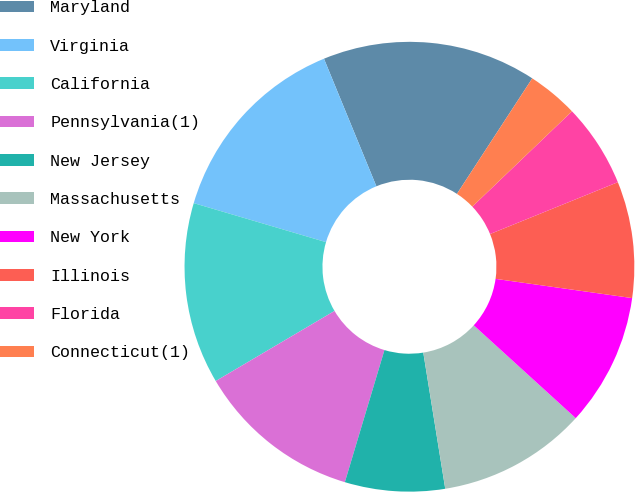Convert chart to OTSL. <chart><loc_0><loc_0><loc_500><loc_500><pie_chart><fcel>Maryland<fcel>Virginia<fcel>California<fcel>Pennsylvania(1)<fcel>New Jersey<fcel>Massachusetts<fcel>New York<fcel>Illinois<fcel>Florida<fcel>Connecticut(1)<nl><fcel>15.4%<fcel>14.23%<fcel>13.05%<fcel>11.88%<fcel>7.18%<fcel>10.7%<fcel>9.53%<fcel>8.36%<fcel>6.01%<fcel>3.66%<nl></chart> 